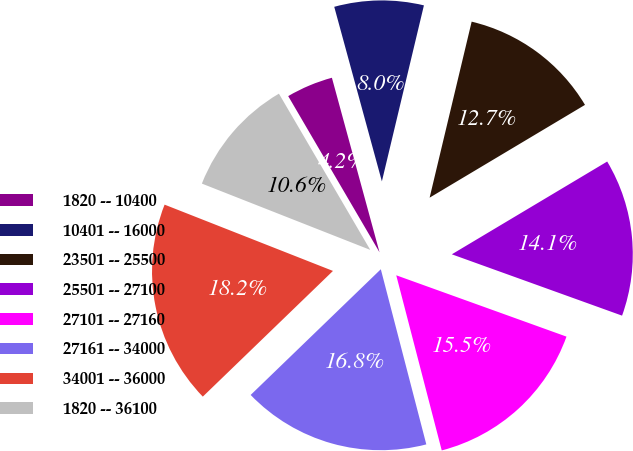Convert chart to OTSL. <chart><loc_0><loc_0><loc_500><loc_500><pie_chart><fcel>1820 -- 10400<fcel>10401 -- 16000<fcel>23501 -- 25500<fcel>25501 -- 27100<fcel>27101 -- 27160<fcel>27161 -- 34000<fcel>34001 -- 36000<fcel>1820 -- 36100<nl><fcel>4.18%<fcel>7.97%<fcel>12.7%<fcel>14.07%<fcel>15.45%<fcel>16.82%<fcel>18.19%<fcel>10.61%<nl></chart> 